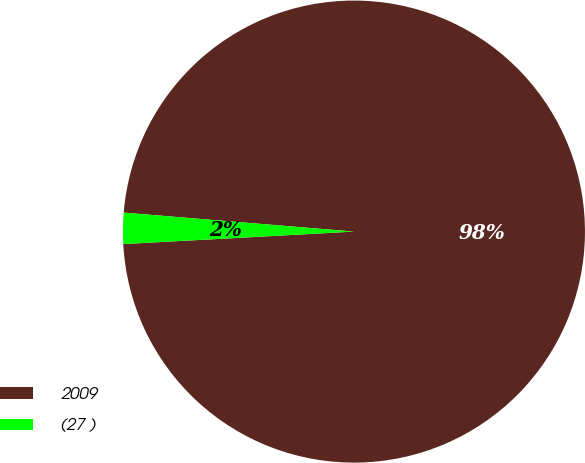Convert chart to OTSL. <chart><loc_0><loc_0><loc_500><loc_500><pie_chart><fcel>2009<fcel>(27 )<nl><fcel>97.83%<fcel>2.17%<nl></chart> 